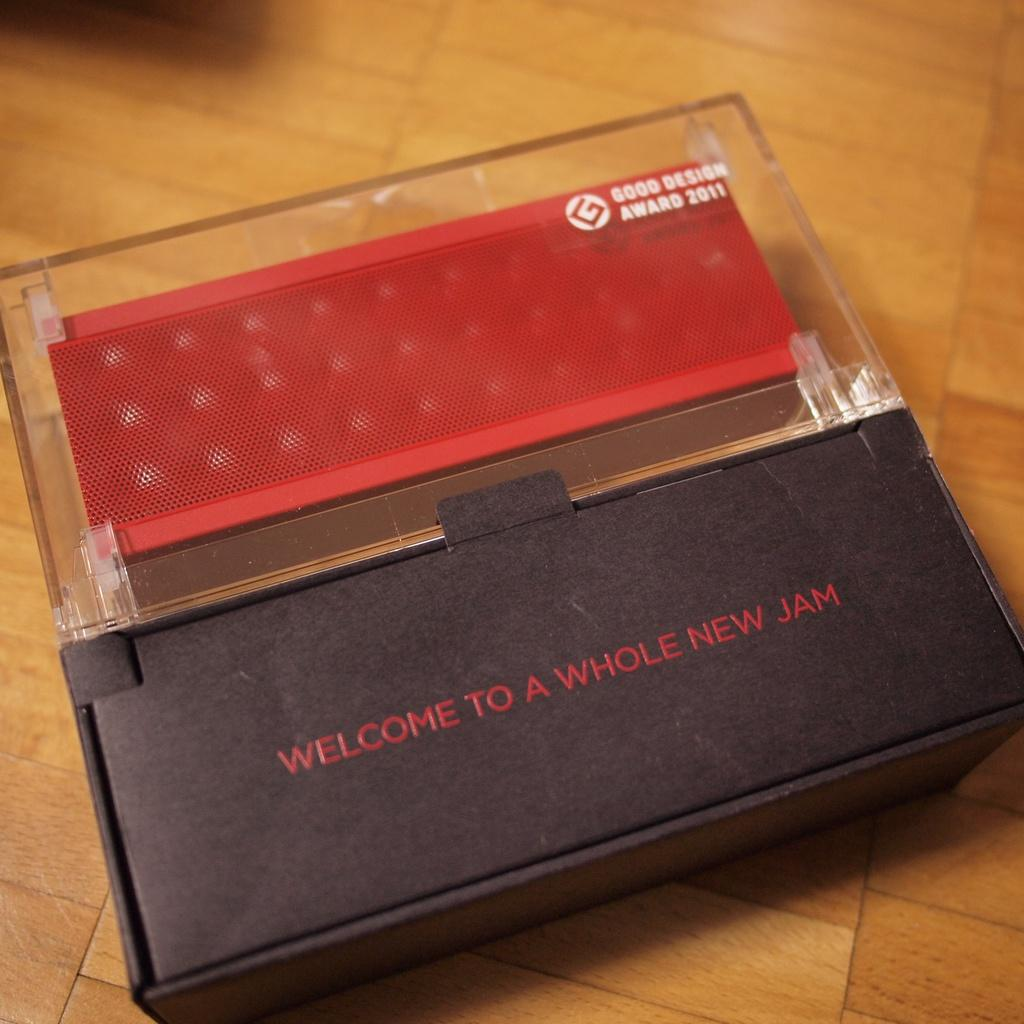<image>
Provide a brief description of the given image. a box that has the words 'welcome to a whole new jam' typed on it in red 